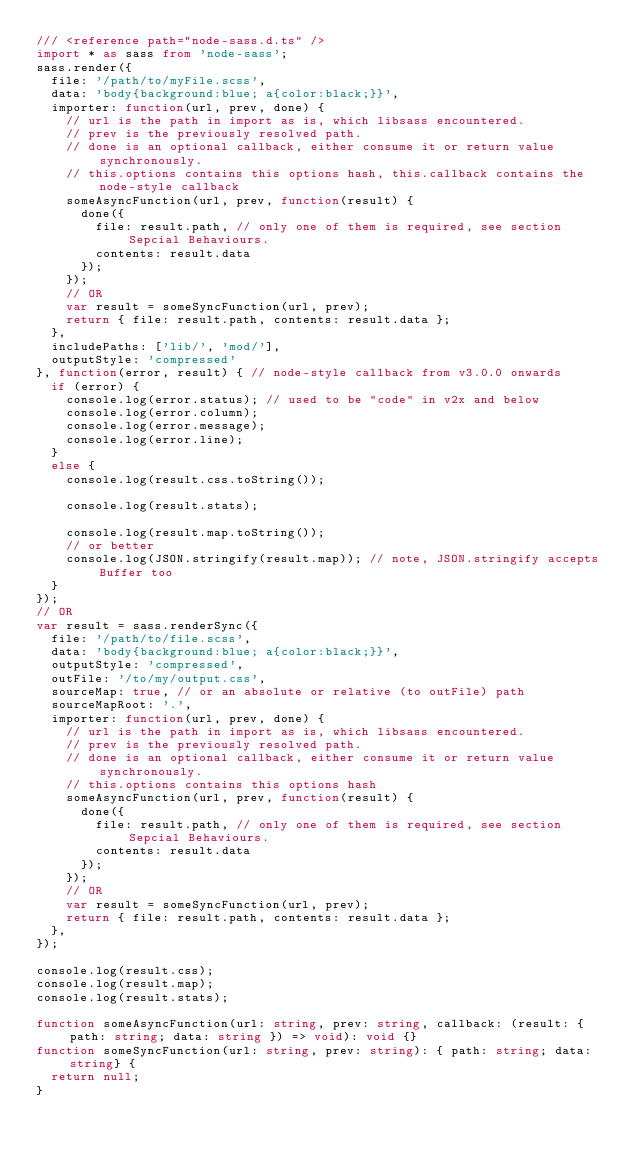<code> <loc_0><loc_0><loc_500><loc_500><_TypeScript_>/// <reference path="node-sass.d.ts" />
import * as sass from 'node-sass';
sass.render({
  file: '/path/to/myFile.scss',
  data: 'body{background:blue; a{color:black;}}',
  importer: function(url, prev, done) {
    // url is the path in import as is, which libsass encountered.
    // prev is the previously resolved path.
    // done is an optional callback, either consume it or return value synchronously.
    // this.options contains this options hash, this.callback contains the node-style callback
    someAsyncFunction(url, prev, function(result) {
      done({
        file: result.path, // only one of them is required, see section Sepcial Behaviours.
        contents: result.data
      });
    });
    // OR
    var result = someSyncFunction(url, prev);
    return { file: result.path, contents: result.data };
  },
  includePaths: ['lib/', 'mod/'],
  outputStyle: 'compressed'
}, function(error, result) { // node-style callback from v3.0.0 onwards
  if (error) {
    console.log(error.status); // used to be "code" in v2x and below
    console.log(error.column);
    console.log(error.message);
    console.log(error.line);
  }
  else {
    console.log(result.css.toString());

    console.log(result.stats);

    console.log(result.map.toString());
    // or better
    console.log(JSON.stringify(result.map)); // note, JSON.stringify accepts Buffer too
  }
});
// OR
var result = sass.renderSync({
  file: '/path/to/file.scss',
  data: 'body{background:blue; a{color:black;}}',
  outputStyle: 'compressed',
  outFile: '/to/my/output.css',
  sourceMap: true, // or an absolute or relative (to outFile) path
  sourceMapRoot: '.',
  importer: function(url, prev, done) {
    // url is the path in import as is, which libsass encountered.
    // prev is the previously resolved path.
    // done is an optional callback, either consume it or return value synchronously.
    // this.options contains this options hash
    someAsyncFunction(url, prev, function(result) {
      done({
        file: result.path, // only one of them is required, see section Sepcial Behaviours.
        contents: result.data
      });
    });
    // OR
    var result = someSyncFunction(url, prev);
    return { file: result.path, contents: result.data };
  },
});

console.log(result.css);
console.log(result.map);
console.log(result.stats);

function someAsyncFunction(url: string, prev: string, callback: (result: { path: string; data: string }) => void): void {}
function someSyncFunction(url: string, prev: string): { path: string; data: string} {
  return null;
}
</code> 